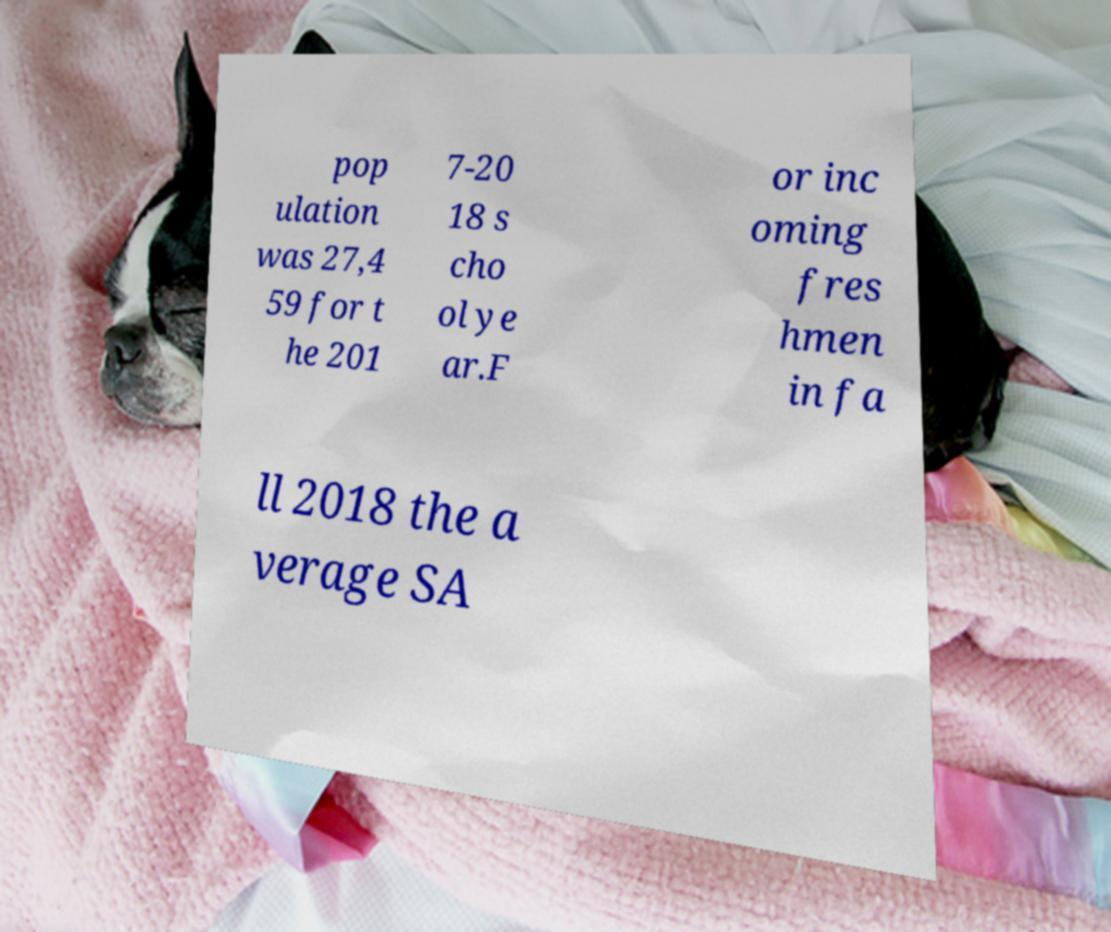Could you extract and type out the text from this image? pop ulation was 27,4 59 for t he 201 7-20 18 s cho ol ye ar.F or inc oming fres hmen in fa ll 2018 the a verage SA 